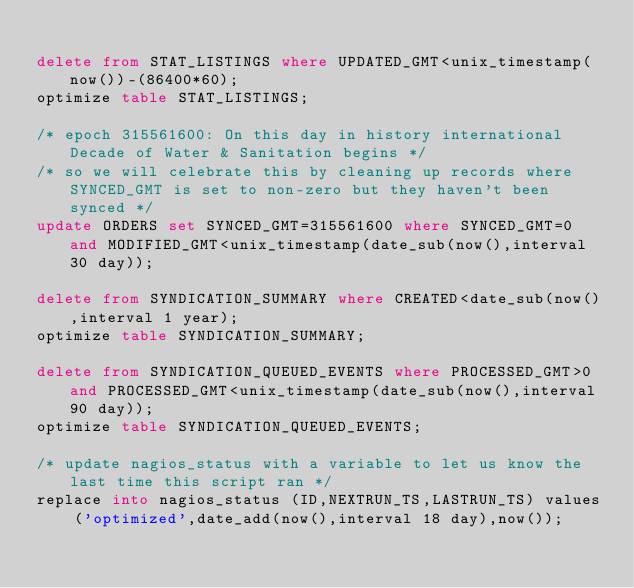Convert code to text. <code><loc_0><loc_0><loc_500><loc_500><_SQL_>
delete from STAT_LISTINGS where UPDATED_GMT<unix_timestamp(now())-(86400*60);
optimize table STAT_LISTINGS;

/* epoch 315561600: On this day in history international Decade of Water & Sanitation begins */ 
/* so we will celebrate this by cleaning up records where SYNCED_GMT is set to non-zero but they haven't been synced */
update ORDERS set SYNCED_GMT=315561600 where SYNCED_GMT=0 and MODIFIED_GMT<unix_timestamp(date_sub(now(),interval 30 day));

delete from SYNDICATION_SUMMARY where CREATED<date_sub(now(),interval 1 year);
optimize table SYNDICATION_SUMMARY;

delete from SYNDICATION_QUEUED_EVENTS where PROCESSED_GMT>0 and PROCESSED_GMT<unix_timestamp(date_sub(now(),interval 90 day));
optimize table SYNDICATION_QUEUED_EVENTS;

/* update nagios_status with a variable to let us know the last time this script ran */
replace into nagios_status (ID,NEXTRUN_TS,LASTRUN_TS) values 
	('optimized',date_add(now(),interval 18 day),now());


</code> 